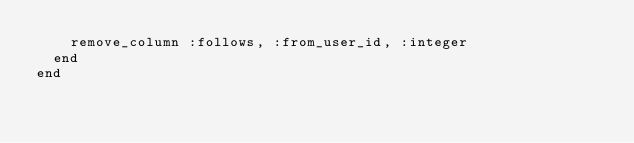<code> <loc_0><loc_0><loc_500><loc_500><_Ruby_>    remove_column :follows, :from_user_id, :integer
  end
end
</code> 